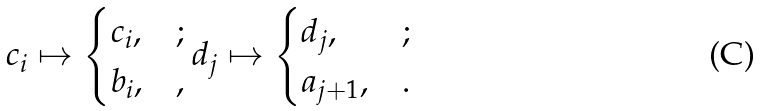Convert formula to latex. <formula><loc_0><loc_0><loc_500><loc_500>c _ { i } \mapsto \begin{cases} c _ { i } , & ; \\ b _ { i } , & , \end{cases} d _ { j } \mapsto \begin{cases} d _ { j } , & ; \\ a _ { j + 1 } , & . \end{cases}</formula> 